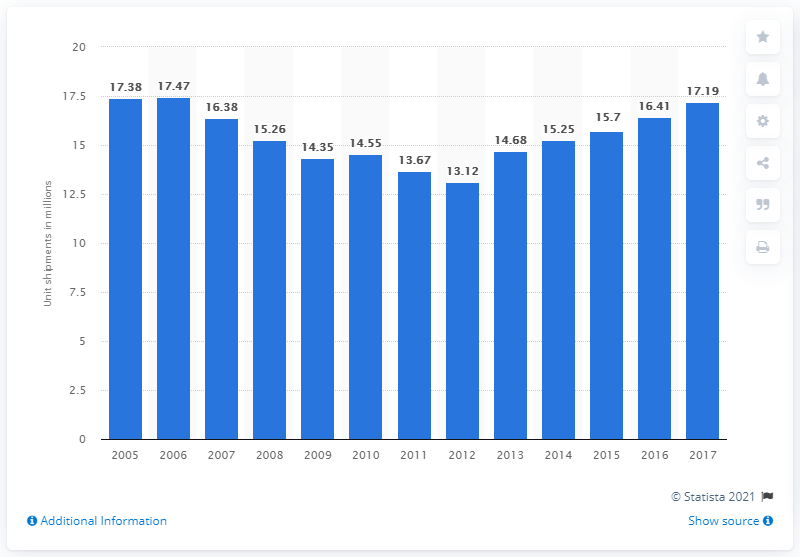List a handful of essential elements in this visual. The estimated total unit shipments of laundry appliances for the year 2015 is 15.7 million units. The forecast for the shipments of electric and gas dryers and automatic washers in 2017 is unknown. 